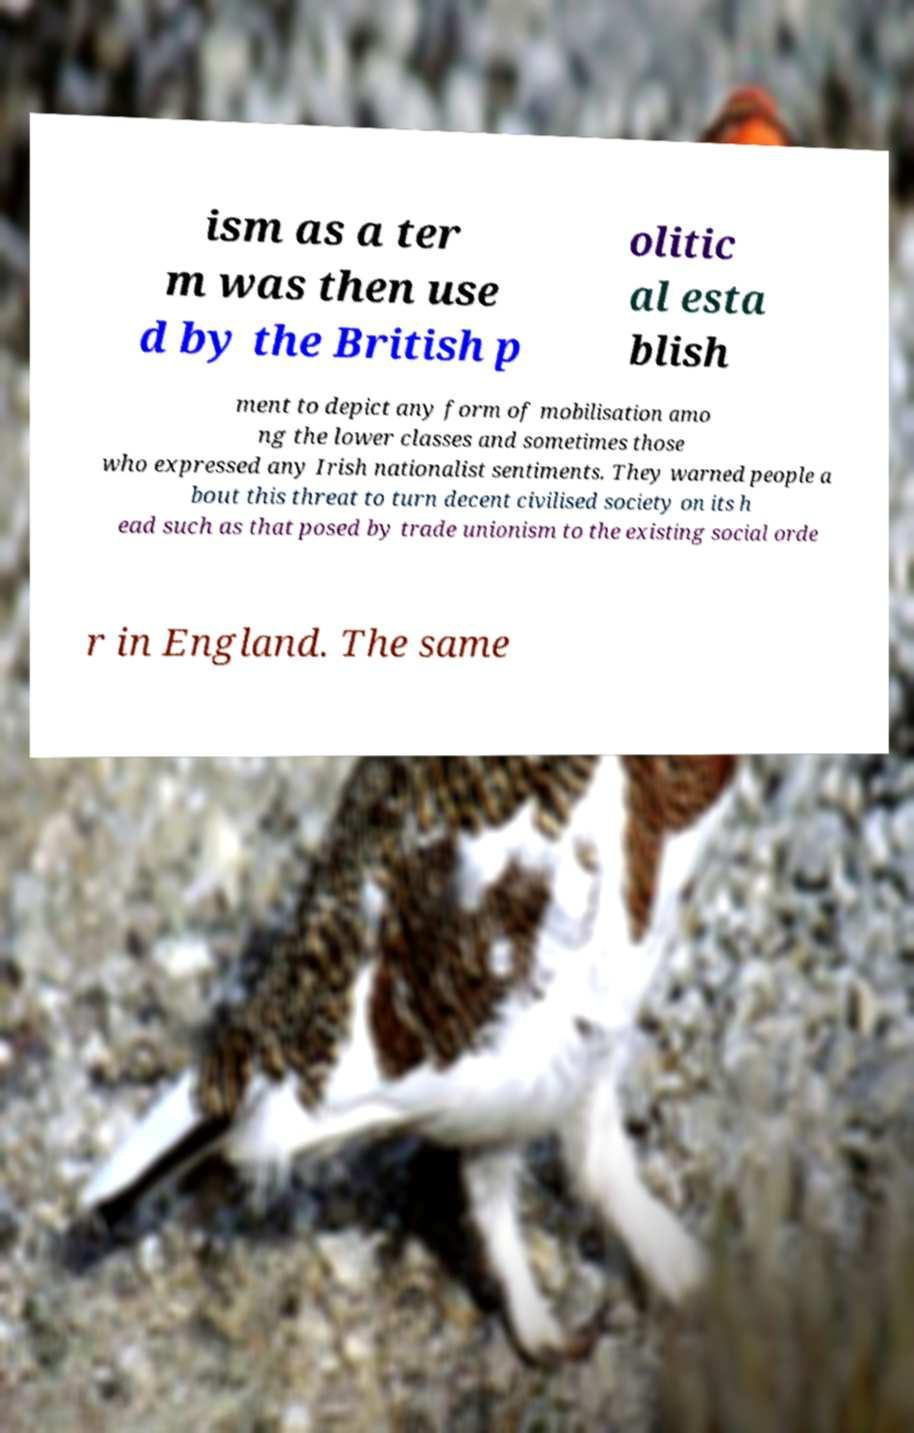Could you extract and type out the text from this image? ism as a ter m was then use d by the British p olitic al esta blish ment to depict any form of mobilisation amo ng the lower classes and sometimes those who expressed any Irish nationalist sentiments. They warned people a bout this threat to turn decent civilised society on its h ead such as that posed by trade unionism to the existing social orde r in England. The same 